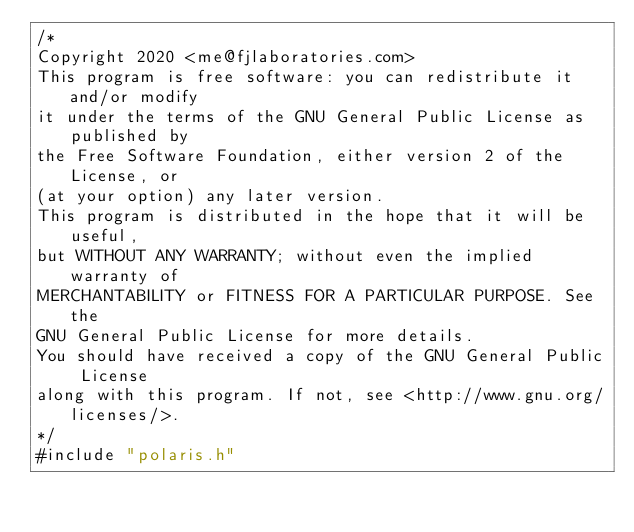Convert code to text. <code><loc_0><loc_0><loc_500><loc_500><_C_>/*
Copyright 2020 <me@fjlaboratories.com>
This program is free software: you can redistribute it and/or modify
it under the terms of the GNU General Public License as published by
the Free Software Foundation, either version 2 of the License, or
(at your option) any later version.
This program is distributed in the hope that it will be useful,
but WITHOUT ANY WARRANTY; without even the implied warranty of
MERCHANTABILITY or FITNESS FOR A PARTICULAR PURPOSE. See the
GNU General Public License for more details.
You should have received a copy of the GNU General Public License
along with this program. If not, see <http://www.gnu.org/licenses/>.
*/
#include "polaris.h"
</code> 